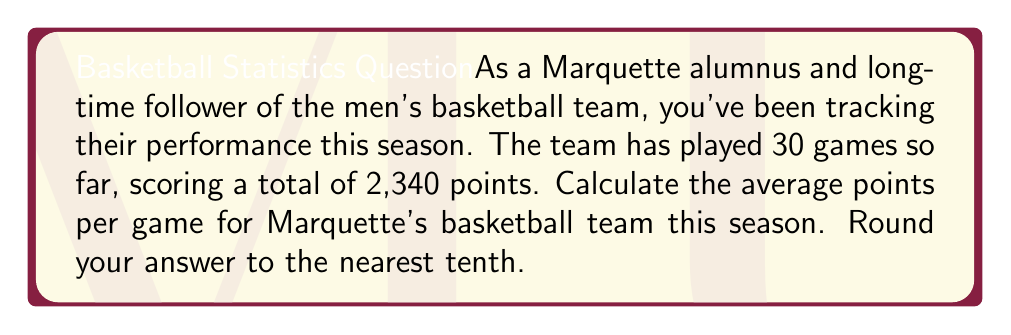Give your solution to this math problem. To calculate the average points per game, we need to use the formula:

$$ \text{Average Points Per Game} = \frac{\text{Total Points Scored}}{\text{Number of Games Played}} $$

Given:
- Total points scored: 2,340
- Number of games played: 30

Let's plug these values into our formula:

$$ \text{Average Points Per Game} = \frac{2,340}{30} $$

Now, let's perform the division:

$$ \text{Average Points Per Game} = 78 $$

Since we're asked to round to the nearest tenth, and 78 is already a whole number, our final answer remains 78.0 points per game.
Answer: 78.0 points per game 